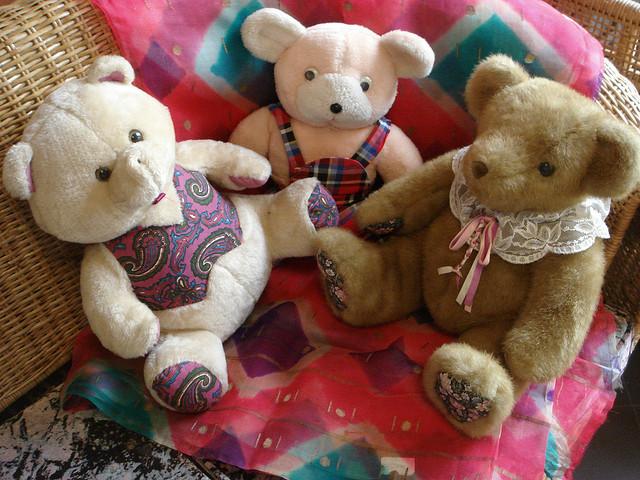Where is the pink bear?
Write a very short answer. Middle. Where is the lace?
Give a very brief answer. In brown bear. How many of the stuffed animals are definitely female?
Concise answer only. 1. 